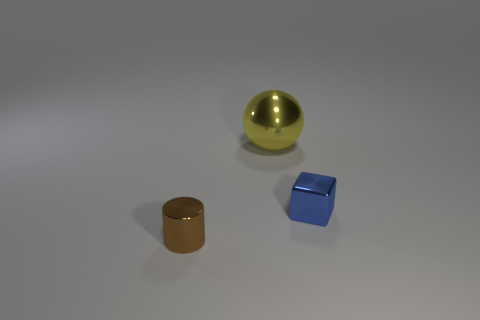Subtract all cylinders. How many objects are left? 2 Add 2 yellow things. How many objects exist? 5 Subtract 1 cubes. How many cubes are left? 0 Subtract all gray cylinders. How many red spheres are left? 0 Subtract all tiny brown shiny cylinders. Subtract all blue blocks. How many objects are left? 1 Add 1 tiny blue shiny things. How many tiny blue shiny things are left? 2 Add 1 small yellow matte blocks. How many small yellow matte blocks exist? 1 Subtract 1 brown cylinders. How many objects are left? 2 Subtract all green spheres. Subtract all purple cubes. How many spheres are left? 1 